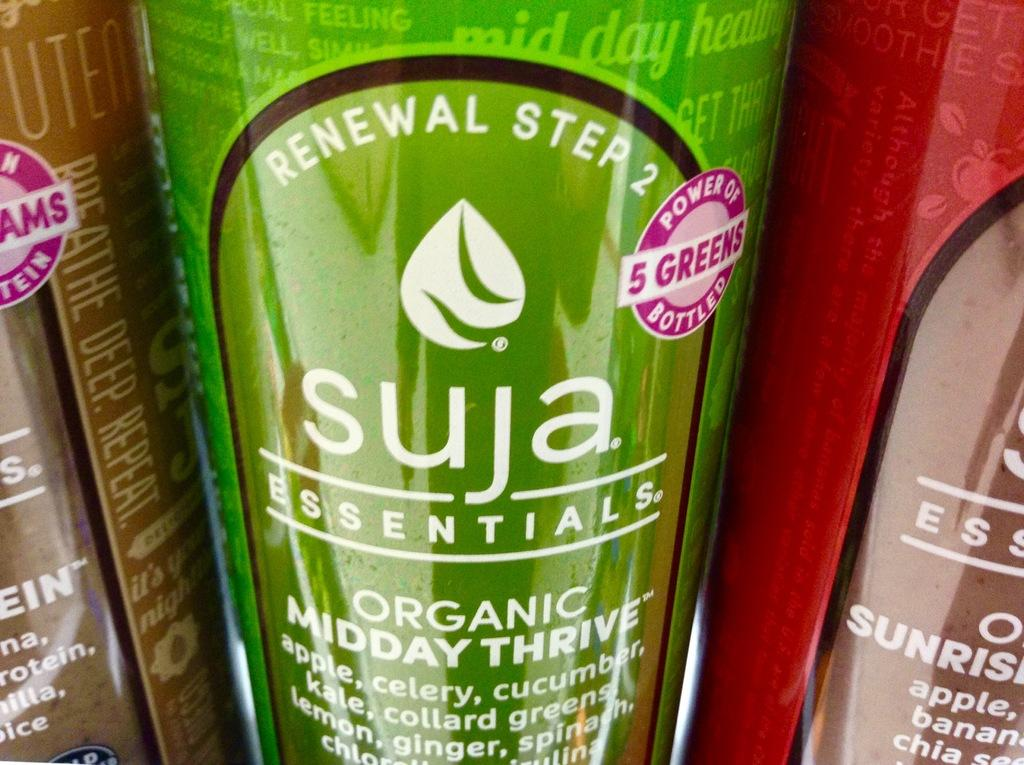<image>
Present a compact description of the photo's key features. a renewal step 2 item that is green in color 